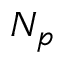<formula> <loc_0><loc_0><loc_500><loc_500>N _ { p }</formula> 